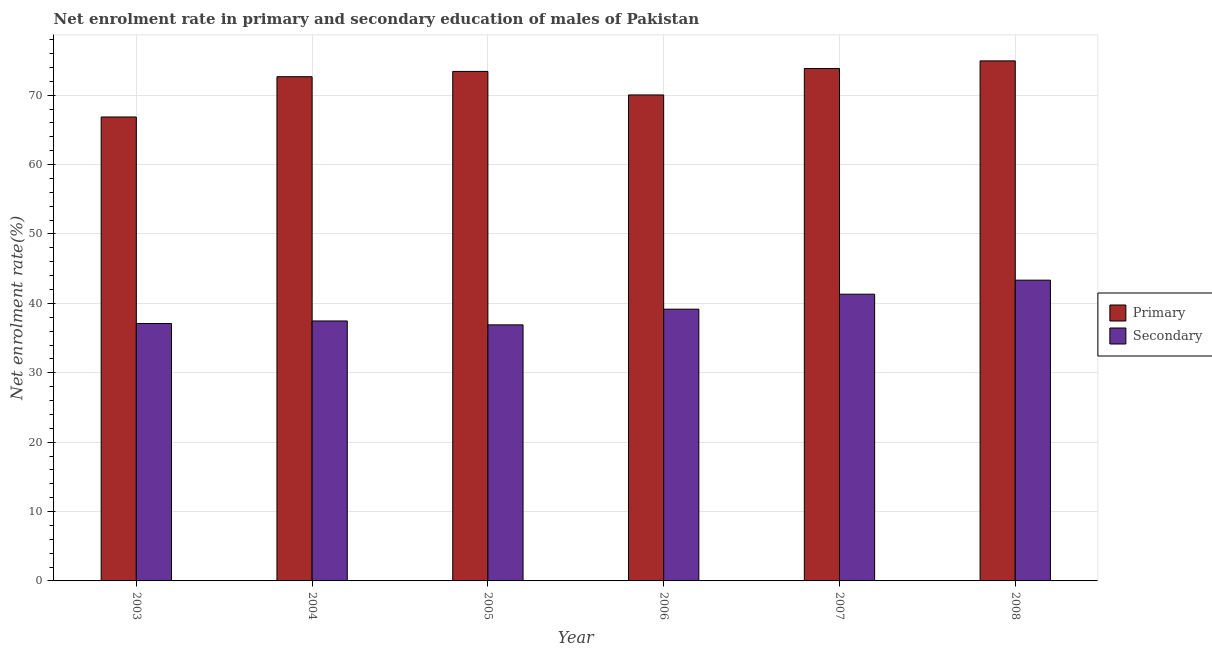Are the number of bars per tick equal to the number of legend labels?
Provide a short and direct response. Yes. Are the number of bars on each tick of the X-axis equal?
Provide a succinct answer. Yes. How many bars are there on the 4th tick from the right?
Provide a short and direct response. 2. What is the label of the 1st group of bars from the left?
Keep it short and to the point. 2003. In how many cases, is the number of bars for a given year not equal to the number of legend labels?
Provide a succinct answer. 0. What is the enrollment rate in primary education in 2007?
Give a very brief answer. 73.85. Across all years, what is the maximum enrollment rate in secondary education?
Your answer should be compact. 43.35. Across all years, what is the minimum enrollment rate in secondary education?
Provide a short and direct response. 36.9. What is the total enrollment rate in secondary education in the graph?
Provide a short and direct response. 235.31. What is the difference between the enrollment rate in primary education in 2007 and that in 2008?
Your answer should be compact. -1.1. What is the difference between the enrollment rate in secondary education in 2008 and the enrollment rate in primary education in 2003?
Provide a short and direct response. 6.24. What is the average enrollment rate in secondary education per year?
Offer a terse response. 39.22. In the year 2008, what is the difference between the enrollment rate in secondary education and enrollment rate in primary education?
Provide a short and direct response. 0. What is the ratio of the enrollment rate in primary education in 2005 to that in 2006?
Provide a short and direct response. 1.05. What is the difference between the highest and the second highest enrollment rate in primary education?
Offer a terse response. 1.1. What is the difference between the highest and the lowest enrollment rate in primary education?
Ensure brevity in your answer.  8.09. In how many years, is the enrollment rate in primary education greater than the average enrollment rate in primary education taken over all years?
Your answer should be compact. 4. What does the 2nd bar from the left in 2007 represents?
Your response must be concise. Secondary. What does the 2nd bar from the right in 2005 represents?
Provide a succinct answer. Primary. Are all the bars in the graph horizontal?
Make the answer very short. No. How many years are there in the graph?
Make the answer very short. 6. Are the values on the major ticks of Y-axis written in scientific E-notation?
Keep it short and to the point. No. Where does the legend appear in the graph?
Provide a short and direct response. Center right. How many legend labels are there?
Give a very brief answer. 2. How are the legend labels stacked?
Your response must be concise. Vertical. What is the title of the graph?
Keep it short and to the point. Net enrolment rate in primary and secondary education of males of Pakistan. What is the label or title of the Y-axis?
Your answer should be compact. Net enrolment rate(%). What is the Net enrolment rate(%) in Primary in 2003?
Your answer should be very brief. 66.86. What is the Net enrolment rate(%) of Secondary in 2003?
Your response must be concise. 37.1. What is the Net enrolment rate(%) of Primary in 2004?
Ensure brevity in your answer.  72.67. What is the Net enrolment rate(%) of Secondary in 2004?
Offer a very short reply. 37.47. What is the Net enrolment rate(%) of Primary in 2005?
Make the answer very short. 73.43. What is the Net enrolment rate(%) in Secondary in 2005?
Your answer should be very brief. 36.9. What is the Net enrolment rate(%) in Primary in 2006?
Give a very brief answer. 70.04. What is the Net enrolment rate(%) of Secondary in 2006?
Make the answer very short. 39.17. What is the Net enrolment rate(%) of Primary in 2007?
Your answer should be very brief. 73.85. What is the Net enrolment rate(%) in Secondary in 2007?
Provide a short and direct response. 41.32. What is the Net enrolment rate(%) in Primary in 2008?
Your response must be concise. 74.95. What is the Net enrolment rate(%) in Secondary in 2008?
Ensure brevity in your answer.  43.35. Across all years, what is the maximum Net enrolment rate(%) in Primary?
Make the answer very short. 74.95. Across all years, what is the maximum Net enrolment rate(%) in Secondary?
Provide a short and direct response. 43.35. Across all years, what is the minimum Net enrolment rate(%) in Primary?
Offer a terse response. 66.86. Across all years, what is the minimum Net enrolment rate(%) in Secondary?
Give a very brief answer. 36.9. What is the total Net enrolment rate(%) in Primary in the graph?
Your answer should be compact. 431.81. What is the total Net enrolment rate(%) of Secondary in the graph?
Make the answer very short. 235.31. What is the difference between the Net enrolment rate(%) in Primary in 2003 and that in 2004?
Offer a terse response. -5.81. What is the difference between the Net enrolment rate(%) in Secondary in 2003 and that in 2004?
Provide a short and direct response. -0.36. What is the difference between the Net enrolment rate(%) in Primary in 2003 and that in 2005?
Provide a succinct answer. -6.57. What is the difference between the Net enrolment rate(%) in Secondary in 2003 and that in 2005?
Your response must be concise. 0.2. What is the difference between the Net enrolment rate(%) of Primary in 2003 and that in 2006?
Your answer should be very brief. -3.18. What is the difference between the Net enrolment rate(%) in Secondary in 2003 and that in 2006?
Your response must be concise. -2.06. What is the difference between the Net enrolment rate(%) in Primary in 2003 and that in 2007?
Offer a terse response. -6.99. What is the difference between the Net enrolment rate(%) in Secondary in 2003 and that in 2007?
Provide a succinct answer. -4.22. What is the difference between the Net enrolment rate(%) of Primary in 2003 and that in 2008?
Give a very brief answer. -8.09. What is the difference between the Net enrolment rate(%) in Secondary in 2003 and that in 2008?
Your answer should be compact. -6.24. What is the difference between the Net enrolment rate(%) in Primary in 2004 and that in 2005?
Offer a very short reply. -0.76. What is the difference between the Net enrolment rate(%) in Secondary in 2004 and that in 2005?
Offer a very short reply. 0.56. What is the difference between the Net enrolment rate(%) in Primary in 2004 and that in 2006?
Your response must be concise. 2.63. What is the difference between the Net enrolment rate(%) in Secondary in 2004 and that in 2006?
Offer a very short reply. -1.7. What is the difference between the Net enrolment rate(%) of Primary in 2004 and that in 2007?
Your answer should be compact. -1.18. What is the difference between the Net enrolment rate(%) of Secondary in 2004 and that in 2007?
Give a very brief answer. -3.86. What is the difference between the Net enrolment rate(%) of Primary in 2004 and that in 2008?
Keep it short and to the point. -2.28. What is the difference between the Net enrolment rate(%) in Secondary in 2004 and that in 2008?
Provide a short and direct response. -5.88. What is the difference between the Net enrolment rate(%) in Primary in 2005 and that in 2006?
Your answer should be compact. 3.39. What is the difference between the Net enrolment rate(%) in Secondary in 2005 and that in 2006?
Provide a short and direct response. -2.26. What is the difference between the Net enrolment rate(%) of Primary in 2005 and that in 2007?
Give a very brief answer. -0.42. What is the difference between the Net enrolment rate(%) in Secondary in 2005 and that in 2007?
Provide a succinct answer. -4.42. What is the difference between the Net enrolment rate(%) in Primary in 2005 and that in 2008?
Offer a terse response. -1.52. What is the difference between the Net enrolment rate(%) in Secondary in 2005 and that in 2008?
Ensure brevity in your answer.  -6.44. What is the difference between the Net enrolment rate(%) of Primary in 2006 and that in 2007?
Offer a very short reply. -3.81. What is the difference between the Net enrolment rate(%) in Secondary in 2006 and that in 2007?
Give a very brief answer. -2.16. What is the difference between the Net enrolment rate(%) in Primary in 2006 and that in 2008?
Give a very brief answer. -4.91. What is the difference between the Net enrolment rate(%) in Secondary in 2006 and that in 2008?
Provide a succinct answer. -4.18. What is the difference between the Net enrolment rate(%) of Primary in 2007 and that in 2008?
Make the answer very short. -1.1. What is the difference between the Net enrolment rate(%) in Secondary in 2007 and that in 2008?
Give a very brief answer. -2.02. What is the difference between the Net enrolment rate(%) of Primary in 2003 and the Net enrolment rate(%) of Secondary in 2004?
Give a very brief answer. 29.4. What is the difference between the Net enrolment rate(%) in Primary in 2003 and the Net enrolment rate(%) in Secondary in 2005?
Keep it short and to the point. 29.96. What is the difference between the Net enrolment rate(%) of Primary in 2003 and the Net enrolment rate(%) of Secondary in 2006?
Provide a succinct answer. 27.7. What is the difference between the Net enrolment rate(%) in Primary in 2003 and the Net enrolment rate(%) in Secondary in 2007?
Make the answer very short. 25.54. What is the difference between the Net enrolment rate(%) in Primary in 2003 and the Net enrolment rate(%) in Secondary in 2008?
Offer a very short reply. 23.52. What is the difference between the Net enrolment rate(%) in Primary in 2004 and the Net enrolment rate(%) in Secondary in 2005?
Your answer should be very brief. 35.77. What is the difference between the Net enrolment rate(%) in Primary in 2004 and the Net enrolment rate(%) in Secondary in 2006?
Provide a succinct answer. 33.5. What is the difference between the Net enrolment rate(%) in Primary in 2004 and the Net enrolment rate(%) in Secondary in 2007?
Your response must be concise. 31.35. What is the difference between the Net enrolment rate(%) of Primary in 2004 and the Net enrolment rate(%) of Secondary in 2008?
Give a very brief answer. 29.32. What is the difference between the Net enrolment rate(%) in Primary in 2005 and the Net enrolment rate(%) in Secondary in 2006?
Provide a succinct answer. 34.27. What is the difference between the Net enrolment rate(%) in Primary in 2005 and the Net enrolment rate(%) in Secondary in 2007?
Ensure brevity in your answer.  32.11. What is the difference between the Net enrolment rate(%) of Primary in 2005 and the Net enrolment rate(%) of Secondary in 2008?
Your response must be concise. 30.09. What is the difference between the Net enrolment rate(%) of Primary in 2006 and the Net enrolment rate(%) of Secondary in 2007?
Provide a short and direct response. 28.72. What is the difference between the Net enrolment rate(%) in Primary in 2006 and the Net enrolment rate(%) in Secondary in 2008?
Offer a very short reply. 26.69. What is the difference between the Net enrolment rate(%) of Primary in 2007 and the Net enrolment rate(%) of Secondary in 2008?
Ensure brevity in your answer.  30.5. What is the average Net enrolment rate(%) in Primary per year?
Offer a very short reply. 71.97. What is the average Net enrolment rate(%) in Secondary per year?
Your answer should be compact. 39.22. In the year 2003, what is the difference between the Net enrolment rate(%) in Primary and Net enrolment rate(%) in Secondary?
Offer a terse response. 29.76. In the year 2004, what is the difference between the Net enrolment rate(%) in Primary and Net enrolment rate(%) in Secondary?
Ensure brevity in your answer.  35.2. In the year 2005, what is the difference between the Net enrolment rate(%) of Primary and Net enrolment rate(%) of Secondary?
Offer a terse response. 36.53. In the year 2006, what is the difference between the Net enrolment rate(%) of Primary and Net enrolment rate(%) of Secondary?
Keep it short and to the point. 30.88. In the year 2007, what is the difference between the Net enrolment rate(%) of Primary and Net enrolment rate(%) of Secondary?
Give a very brief answer. 32.53. In the year 2008, what is the difference between the Net enrolment rate(%) of Primary and Net enrolment rate(%) of Secondary?
Ensure brevity in your answer.  31.6. What is the ratio of the Net enrolment rate(%) of Primary in 2003 to that in 2004?
Your answer should be compact. 0.92. What is the ratio of the Net enrolment rate(%) of Secondary in 2003 to that in 2004?
Your answer should be very brief. 0.99. What is the ratio of the Net enrolment rate(%) in Primary in 2003 to that in 2005?
Provide a short and direct response. 0.91. What is the ratio of the Net enrolment rate(%) of Secondary in 2003 to that in 2005?
Make the answer very short. 1.01. What is the ratio of the Net enrolment rate(%) in Primary in 2003 to that in 2006?
Ensure brevity in your answer.  0.95. What is the ratio of the Net enrolment rate(%) of Secondary in 2003 to that in 2006?
Make the answer very short. 0.95. What is the ratio of the Net enrolment rate(%) of Primary in 2003 to that in 2007?
Make the answer very short. 0.91. What is the ratio of the Net enrolment rate(%) in Secondary in 2003 to that in 2007?
Offer a terse response. 0.9. What is the ratio of the Net enrolment rate(%) in Primary in 2003 to that in 2008?
Offer a terse response. 0.89. What is the ratio of the Net enrolment rate(%) in Secondary in 2003 to that in 2008?
Your response must be concise. 0.86. What is the ratio of the Net enrolment rate(%) in Secondary in 2004 to that in 2005?
Provide a short and direct response. 1.02. What is the ratio of the Net enrolment rate(%) of Primary in 2004 to that in 2006?
Provide a succinct answer. 1.04. What is the ratio of the Net enrolment rate(%) of Secondary in 2004 to that in 2006?
Provide a short and direct response. 0.96. What is the ratio of the Net enrolment rate(%) of Primary in 2004 to that in 2007?
Offer a very short reply. 0.98. What is the ratio of the Net enrolment rate(%) in Secondary in 2004 to that in 2007?
Keep it short and to the point. 0.91. What is the ratio of the Net enrolment rate(%) in Primary in 2004 to that in 2008?
Make the answer very short. 0.97. What is the ratio of the Net enrolment rate(%) of Secondary in 2004 to that in 2008?
Keep it short and to the point. 0.86. What is the ratio of the Net enrolment rate(%) of Primary in 2005 to that in 2006?
Offer a very short reply. 1.05. What is the ratio of the Net enrolment rate(%) in Secondary in 2005 to that in 2006?
Ensure brevity in your answer.  0.94. What is the ratio of the Net enrolment rate(%) of Primary in 2005 to that in 2007?
Make the answer very short. 0.99. What is the ratio of the Net enrolment rate(%) in Secondary in 2005 to that in 2007?
Ensure brevity in your answer.  0.89. What is the ratio of the Net enrolment rate(%) in Primary in 2005 to that in 2008?
Your response must be concise. 0.98. What is the ratio of the Net enrolment rate(%) in Secondary in 2005 to that in 2008?
Ensure brevity in your answer.  0.85. What is the ratio of the Net enrolment rate(%) of Primary in 2006 to that in 2007?
Ensure brevity in your answer.  0.95. What is the ratio of the Net enrolment rate(%) of Secondary in 2006 to that in 2007?
Give a very brief answer. 0.95. What is the ratio of the Net enrolment rate(%) of Primary in 2006 to that in 2008?
Offer a very short reply. 0.93. What is the ratio of the Net enrolment rate(%) of Secondary in 2006 to that in 2008?
Provide a succinct answer. 0.9. What is the ratio of the Net enrolment rate(%) of Primary in 2007 to that in 2008?
Keep it short and to the point. 0.99. What is the ratio of the Net enrolment rate(%) in Secondary in 2007 to that in 2008?
Your answer should be very brief. 0.95. What is the difference between the highest and the second highest Net enrolment rate(%) of Primary?
Provide a short and direct response. 1.1. What is the difference between the highest and the second highest Net enrolment rate(%) of Secondary?
Provide a short and direct response. 2.02. What is the difference between the highest and the lowest Net enrolment rate(%) of Primary?
Offer a terse response. 8.09. What is the difference between the highest and the lowest Net enrolment rate(%) of Secondary?
Your answer should be very brief. 6.44. 